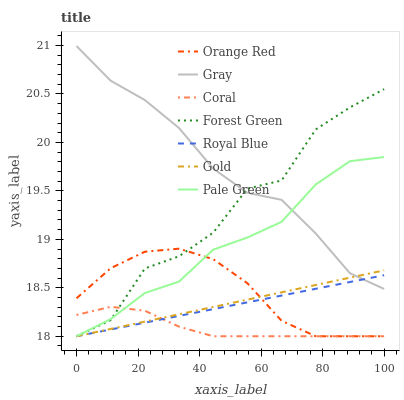Does Coral have the minimum area under the curve?
Answer yes or no. Yes. Does Gray have the maximum area under the curve?
Answer yes or no. Yes. Does Gold have the minimum area under the curve?
Answer yes or no. No. Does Gold have the maximum area under the curve?
Answer yes or no. No. Is Royal Blue the smoothest?
Answer yes or no. Yes. Is Forest Green the roughest?
Answer yes or no. Yes. Is Gold the smoothest?
Answer yes or no. No. Is Gold the roughest?
Answer yes or no. No. Does Gold have the lowest value?
Answer yes or no. Yes. Does Gray have the highest value?
Answer yes or no. Yes. Does Gold have the highest value?
Answer yes or no. No. Is Coral less than Gray?
Answer yes or no. Yes. Is Gray greater than Coral?
Answer yes or no. Yes. Does Royal Blue intersect Coral?
Answer yes or no. Yes. Is Royal Blue less than Coral?
Answer yes or no. No. Is Royal Blue greater than Coral?
Answer yes or no. No. Does Coral intersect Gray?
Answer yes or no. No. 